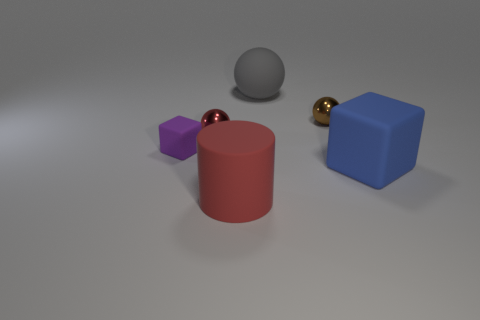Subtract all tiny balls. How many balls are left? 1 Add 2 tiny purple matte cubes. How many objects exist? 8 Subtract all cylinders. How many objects are left? 5 Subtract all blue blocks. How many blocks are left? 1 Subtract 3 spheres. How many spheres are left? 0 Add 6 brown shiny objects. How many brown shiny objects are left? 7 Add 5 red matte things. How many red matte things exist? 6 Subtract 0 green cylinders. How many objects are left? 6 Subtract all yellow blocks. Subtract all cyan balls. How many blocks are left? 2 Subtract all red spheres. How many blue cylinders are left? 0 